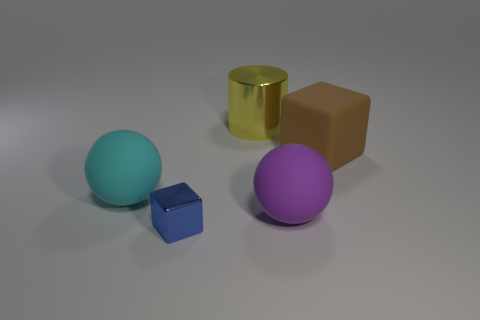Can you tell me the colors of the spheres in the picture? Certainly! In the image, there are two spheres: one is cyan and the other is purple. 